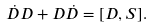Convert formula to latex. <formula><loc_0><loc_0><loc_500><loc_500>\dot { D } D + D \dot { D } = [ D , S ] .</formula> 